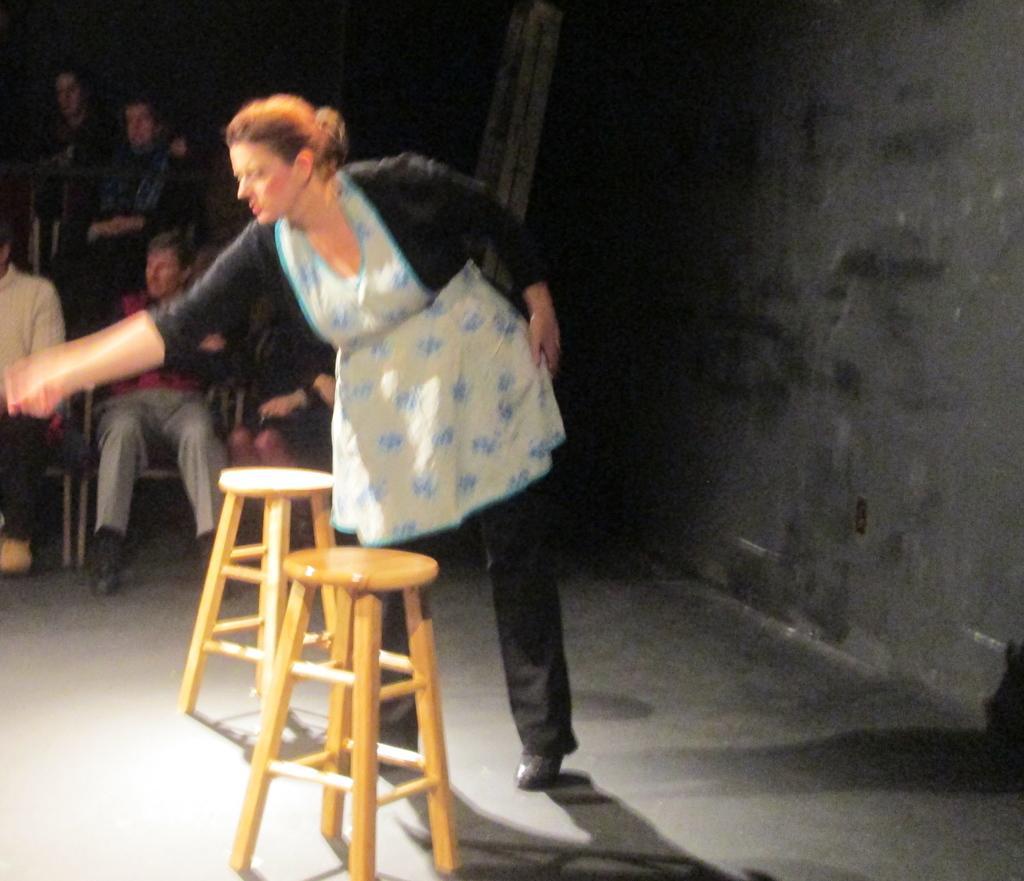Please provide a concise description of this image. In this picture i could see a woman with a white dress and black pant standing and seems like it is a play. There are two chairs in front of her and in the back ground to the left side of the picture i could see some persons sitting on the chair and to the right side of the picture there is a black wall as a background. 